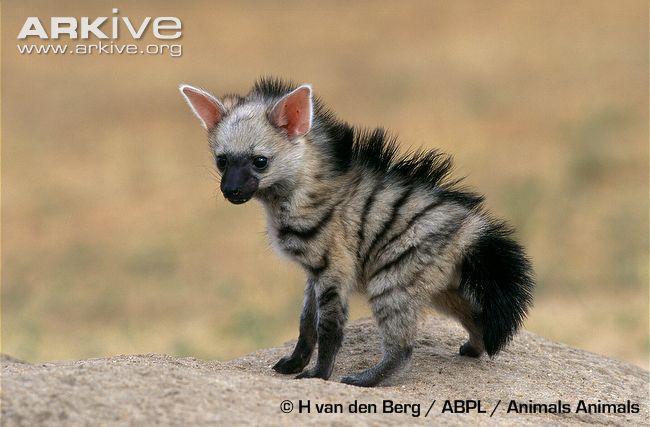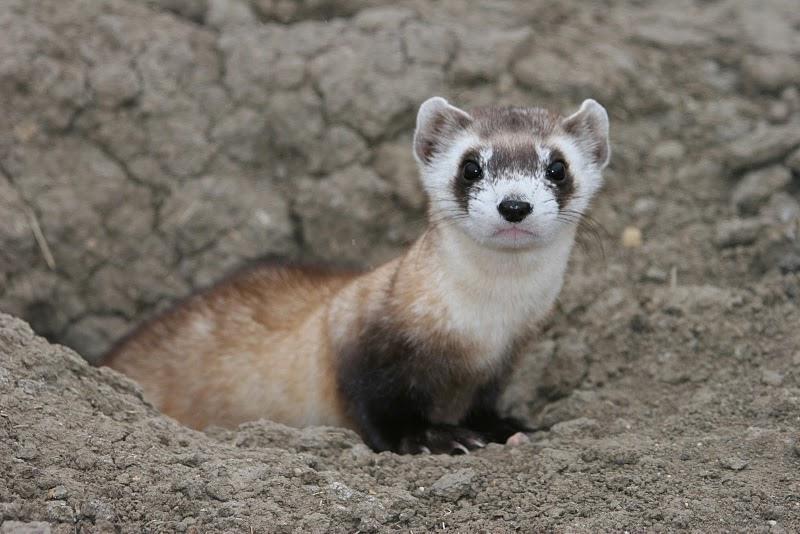The first image is the image on the left, the second image is the image on the right. Considering the images on both sides, is "The Muscatel is partly viable as they come out of the dirt hole in the ground." valid? Answer yes or no. Yes. The first image is the image on the left, the second image is the image on the right. Evaluate the accuracy of this statement regarding the images: "There are exactly two animals and one is emerging from a hole in the dirt.". Is it true? Answer yes or no. Yes. 